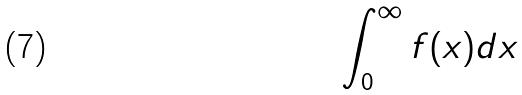Convert formula to latex. <formula><loc_0><loc_0><loc_500><loc_500>\int _ { 0 } ^ { \infty } f ( x ) d x</formula> 